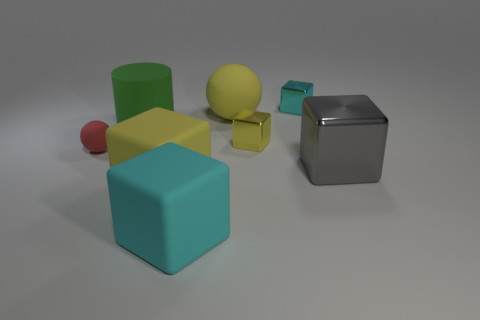Subtract all red cubes. Subtract all blue spheres. How many cubes are left? 5 Add 1 red things. How many objects exist? 9 Subtract all cubes. How many objects are left? 3 Add 3 big yellow matte balls. How many big yellow matte balls exist? 4 Subtract 1 green cylinders. How many objects are left? 7 Subtract all tiny yellow metal cubes. Subtract all gray metallic blocks. How many objects are left? 6 Add 3 matte things. How many matte things are left? 8 